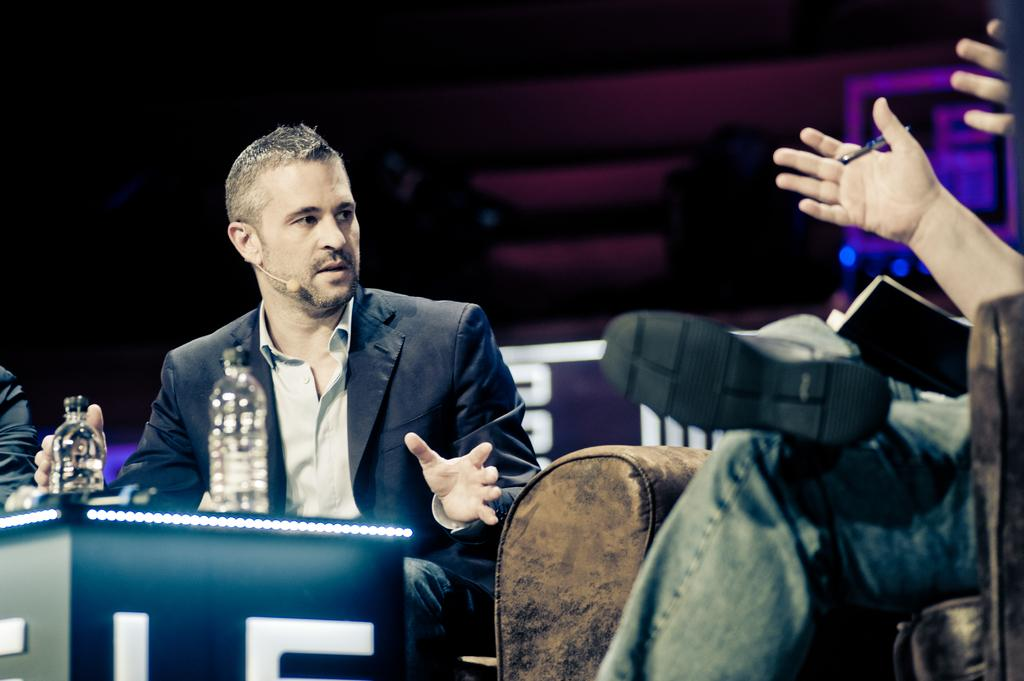What is the main subject in the center of the image? There is a man sitting in the center of the image. What is the man on the right side of the image doing? The man on the right side of the image is sitting and holding a pen in his hands. What objects can be seen on the table in the front of the image? Bottles are placed on a table in the front of the image. How many corn plants can be seen in the image? There is no corn present in the image. What type of bears are visible in the image? There are no bears present in the image. 